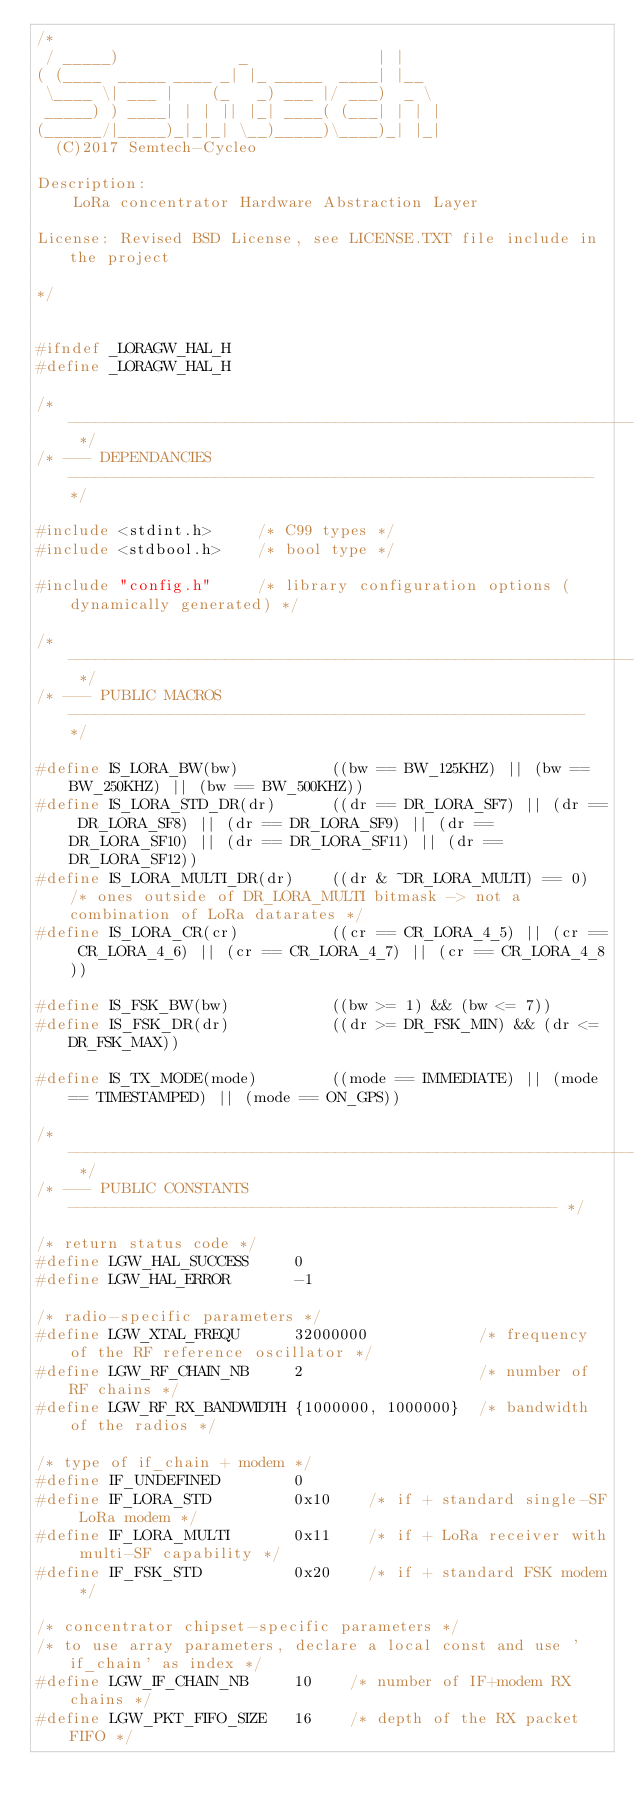Convert code to text. <code><loc_0><loc_0><loc_500><loc_500><_C_>/*
 / _____)             _              | |
( (____  _____ ____ _| |_ _____  ____| |__
 \____ \| ___ |    (_   _) ___ |/ ___)  _ \
 _____) ) ____| | | || |_| ____( (___| | | |
(______/|_____)_|_|_| \__)_____)\____)_| |_|
  (C)2017 Semtech-Cycleo

Description:
    LoRa concentrator Hardware Abstraction Layer

License: Revised BSD License, see LICENSE.TXT file include in the project

*/


#ifndef _LORAGW_HAL_H
#define _LORAGW_HAL_H

/* -------------------------------------------------------------------------- */
/* --- DEPENDANCIES --------------------------------------------------------- */

#include <stdint.h>     /* C99 types */
#include <stdbool.h>    /* bool type */

#include "config.h"     /* library configuration options (dynamically generated) */

/* -------------------------------------------------------------------------- */
/* --- PUBLIC MACROS -------------------------------------------------------- */

#define IS_LORA_BW(bw)          ((bw == BW_125KHZ) || (bw == BW_250KHZ) || (bw == BW_500KHZ))
#define IS_LORA_STD_DR(dr)      ((dr == DR_LORA_SF7) || (dr == DR_LORA_SF8) || (dr == DR_LORA_SF9) || (dr == DR_LORA_SF10) || (dr == DR_LORA_SF11) || (dr == DR_LORA_SF12))
#define IS_LORA_MULTI_DR(dr)    ((dr & ~DR_LORA_MULTI) == 0) /* ones outside of DR_LORA_MULTI bitmask -> not a combination of LoRa datarates */
#define IS_LORA_CR(cr)          ((cr == CR_LORA_4_5) || (cr == CR_LORA_4_6) || (cr == CR_LORA_4_7) || (cr == CR_LORA_4_8))

#define IS_FSK_BW(bw)           ((bw >= 1) && (bw <= 7))
#define IS_FSK_DR(dr)           ((dr >= DR_FSK_MIN) && (dr <= DR_FSK_MAX))

#define IS_TX_MODE(mode)        ((mode == IMMEDIATE) || (mode == TIMESTAMPED) || (mode == ON_GPS))

/* -------------------------------------------------------------------------- */
/* --- PUBLIC CONSTANTS ----------------------------------------------------- */

/* return status code */
#define LGW_HAL_SUCCESS     0
#define LGW_HAL_ERROR       -1

/* radio-specific parameters */
#define LGW_XTAL_FREQU      32000000            /* frequency of the RF reference oscillator */
#define LGW_RF_CHAIN_NB     2                   /* number of RF chains */
#define LGW_RF_RX_BANDWIDTH {1000000, 1000000}  /* bandwidth of the radios */

/* type of if_chain + modem */
#define IF_UNDEFINED        0
#define IF_LORA_STD         0x10    /* if + standard single-SF LoRa modem */
#define IF_LORA_MULTI       0x11    /* if + LoRa receiver with multi-SF capability */
#define IF_FSK_STD          0x20    /* if + standard FSK modem */

/* concentrator chipset-specific parameters */
/* to use array parameters, declare a local const and use 'if_chain' as index */
#define LGW_IF_CHAIN_NB     10    /* number of IF+modem RX chains */
#define LGW_PKT_FIFO_SIZE   16    /* depth of the RX packet FIFO */</code> 